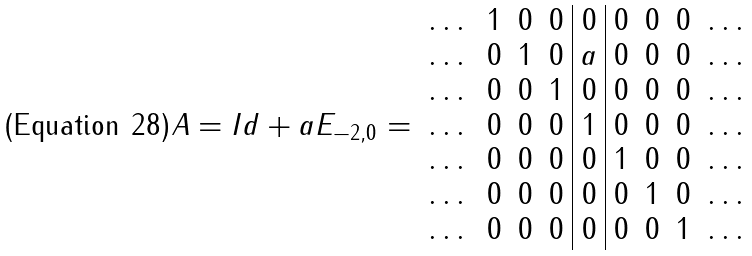Convert formula to latex. <formula><loc_0><loc_0><loc_500><loc_500>A = I d + a E _ { - 2 , 0 } = \begin{array} { r r r r | c | r r r c } \dots & 1 & 0 & 0 & 0 & 0 & 0 & 0 & \dots \\ \dots & 0 & 1 & 0 & a & 0 & 0 & 0 & \dots \\ \dots & 0 & 0 & 1 & 0 & 0 & 0 & 0 & \dots \\ \dots & 0 & 0 & 0 & 1 & 0 & 0 & 0 & \dots \\ \dots & 0 & 0 & 0 & 0 & 1 & 0 & 0 & \dots \\ \dots & 0 & 0 & 0 & 0 & 0 & 1 & 0 & \dots \\ \dots & 0 & 0 & 0 & 0 & 0 & 0 & 1 & \dots \\ \end{array}</formula> 